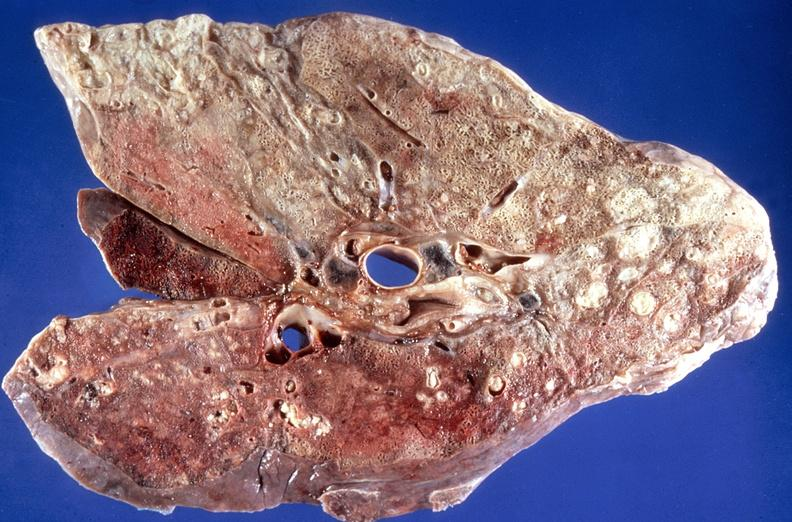does hematologic show lung, bronchopneumonia, cystic fibrosis?
Answer the question using a single word or phrase. No 